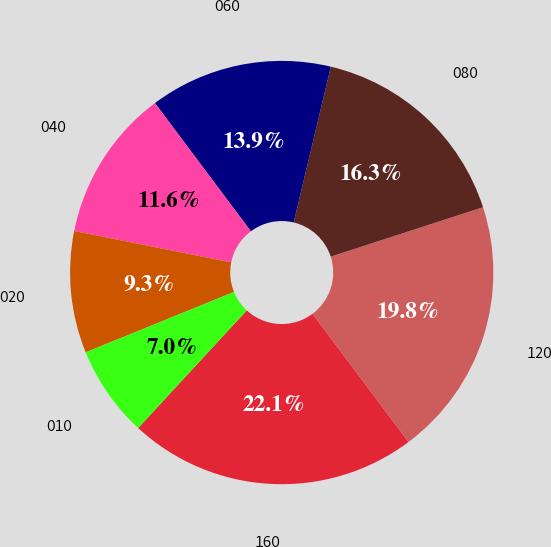<chart> <loc_0><loc_0><loc_500><loc_500><pie_chart><fcel>160<fcel>120<fcel>080<fcel>060<fcel>040<fcel>020<fcel>010<nl><fcel>22.09%<fcel>19.77%<fcel>16.28%<fcel>13.95%<fcel>11.63%<fcel>9.3%<fcel>6.98%<nl></chart> 